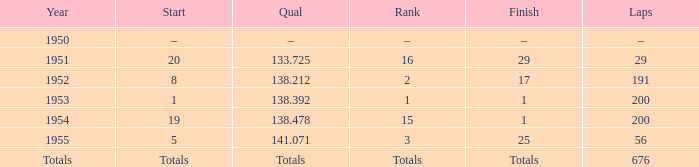What is the start of the race with 676 laps? Totals. 